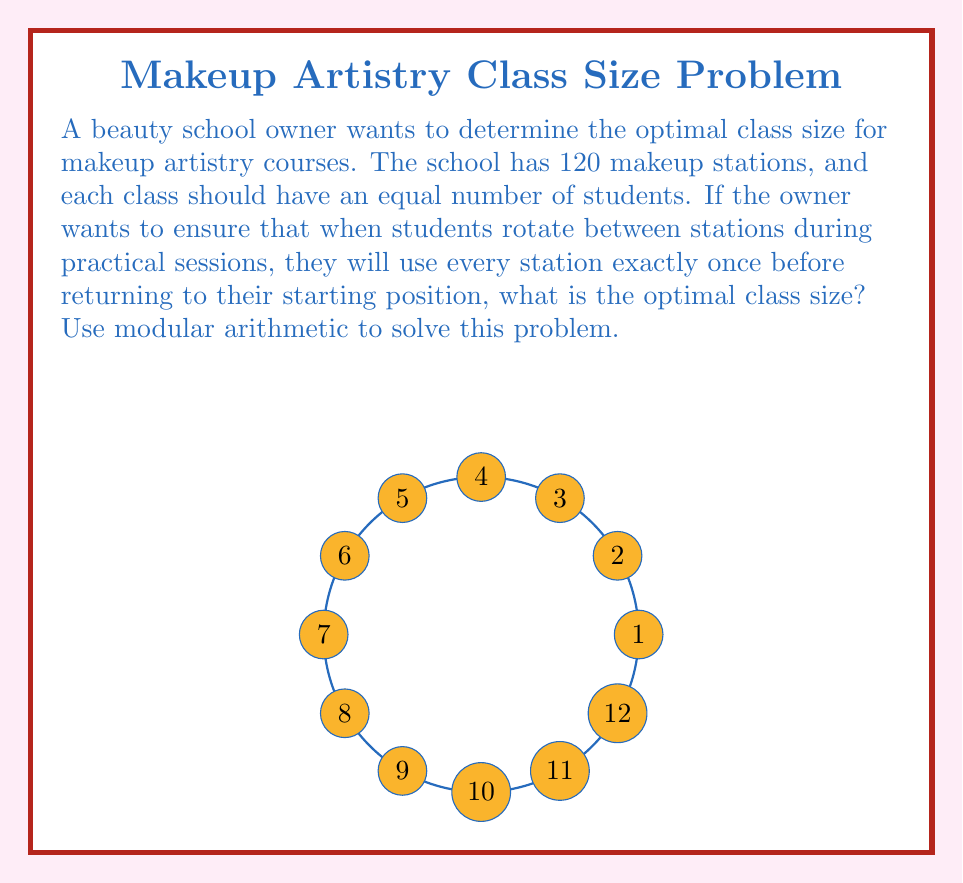Teach me how to tackle this problem. Let's approach this step-by-step using modular arithmetic:

1) Let $x$ be the number of students in a class.

2) For students to use every station exactly once before returning to their starting position, we need:

   $120 \equiv 0 \pmod{x}$

3) This means that $x$ must be a divisor of 120.

4) The divisors of 120 are: 1, 2, 3, 4, 5, 6, 8, 10, 12, 15, 20, 24, 30, 40, 60, 120.

5) However, we need to consider practical constraints. A very small class size (like 1, 2, or 3) or a very large one (like 60 or 120) would not be optimal for a makeup artistry course.

6) Among the reasonable options, we should choose the largest one to maximize enrollment while ensuring each student gets to use all stations.

7) The largest reasonable option is 30.

8) We can verify: $120 \equiv 0 \pmod{30}$

9) With 30 students, each student will use 4 different stations (120 ÷ 30 = 4) before returning to their starting position, which is a good number for a practical session.

Therefore, the optimal class size is 30 students.
Answer: 30 students 